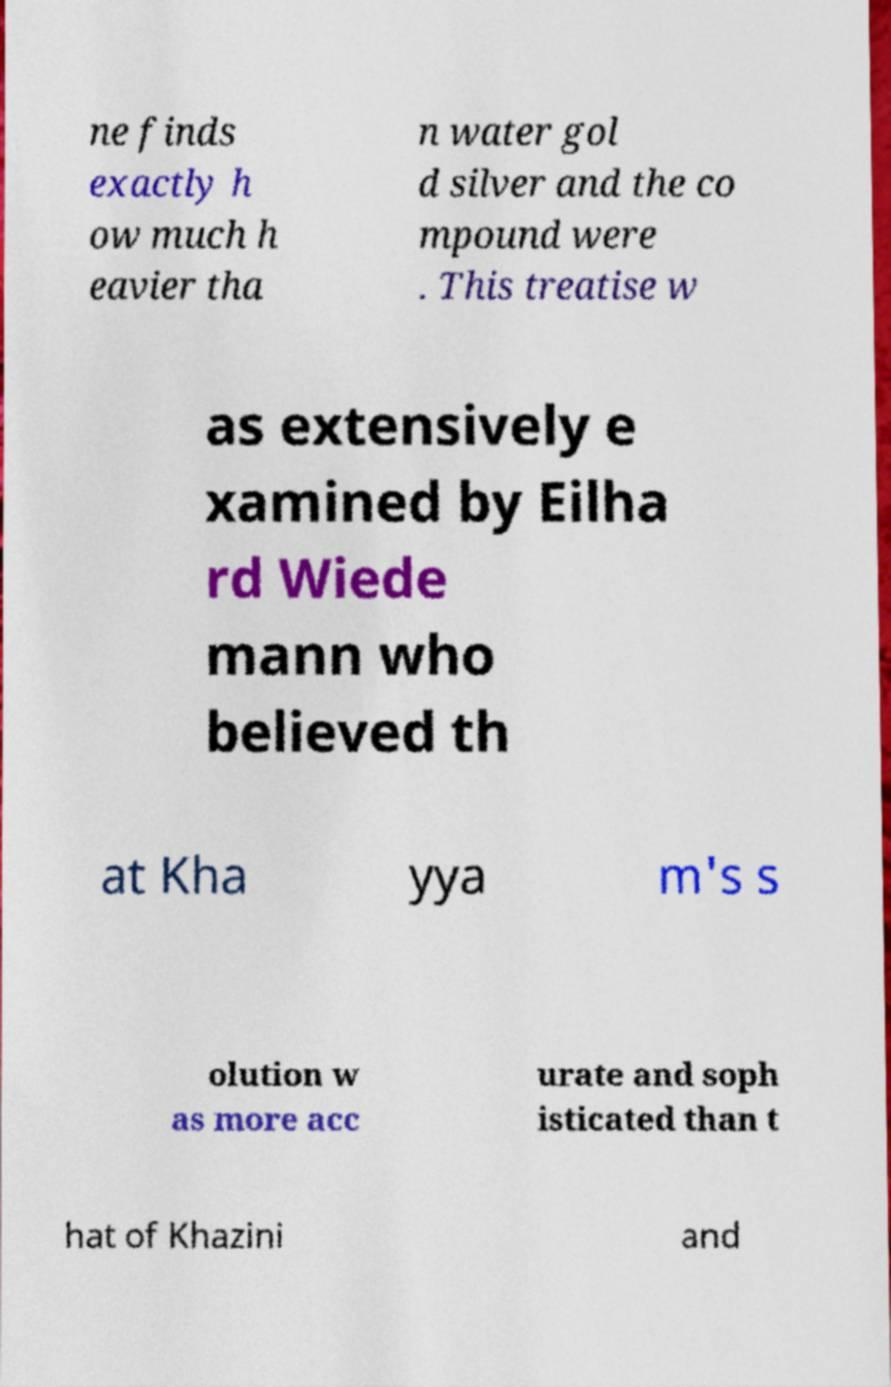Could you extract and type out the text from this image? ne finds exactly h ow much h eavier tha n water gol d silver and the co mpound were . This treatise w as extensively e xamined by Eilha rd Wiede mann who believed th at Kha yya m's s olution w as more acc urate and soph isticated than t hat of Khazini and 